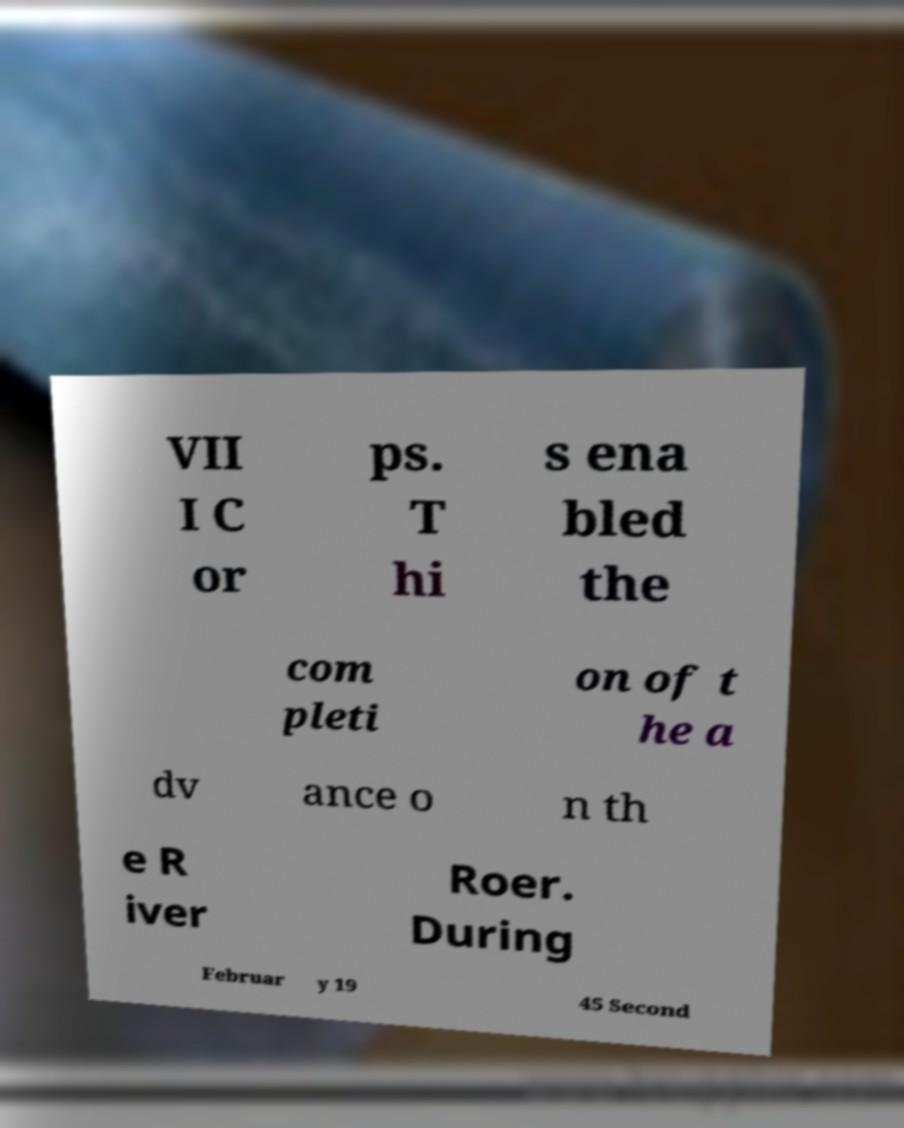What messages or text are displayed in this image? I need them in a readable, typed format. VII I C or ps. T hi s ena bled the com pleti on of t he a dv ance o n th e R iver Roer. During Februar y 19 45 Second 